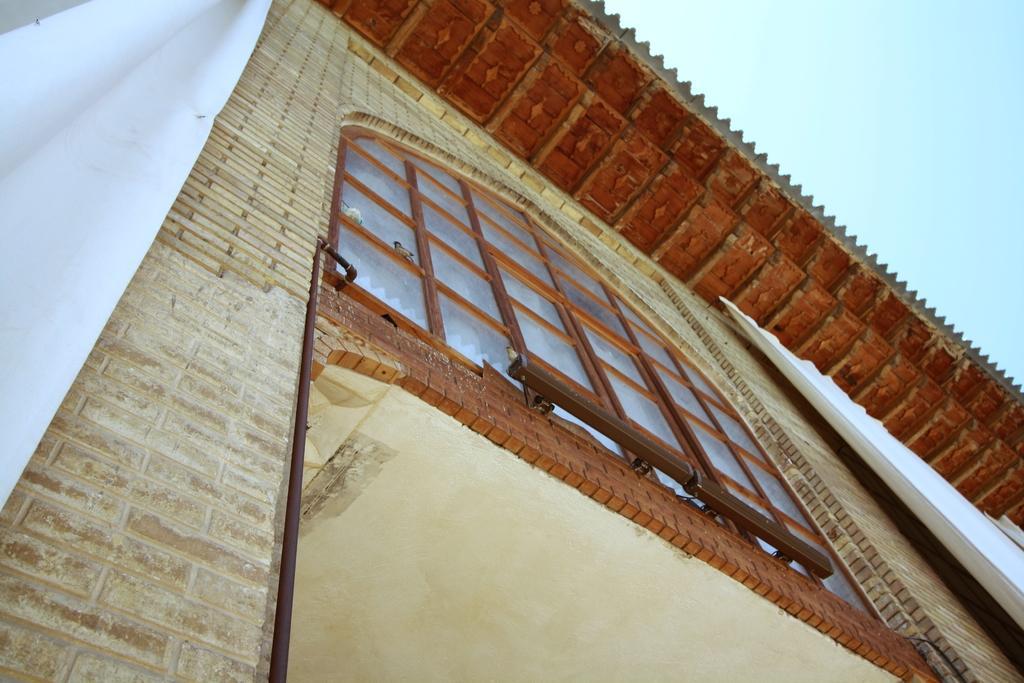Please provide a concise description of this image. In this picture there is a house in the center of the image, on which there is a window and curtains in the image. 